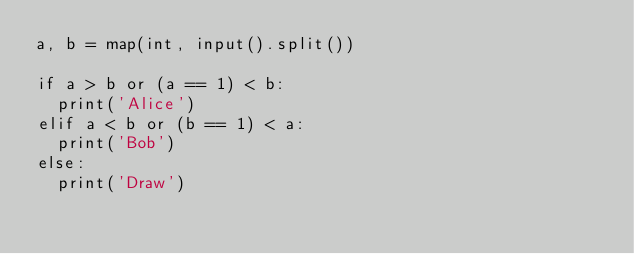<code> <loc_0><loc_0><loc_500><loc_500><_Python_>a, b = map(int, input().split())

if a > b or (a == 1) < b:
  print('Alice')
elif a < b or (b == 1) < a:
  print('Bob')
else:
  print('Draw')</code> 